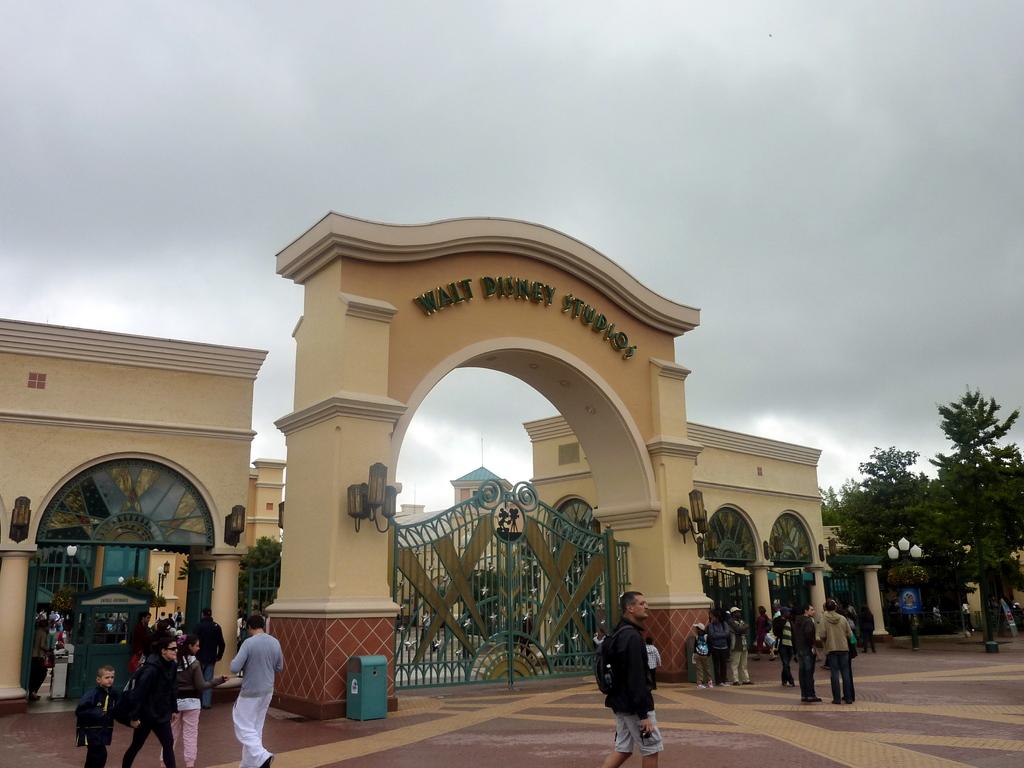Where do these gates lead?
Make the answer very short. Walt disney studios. 